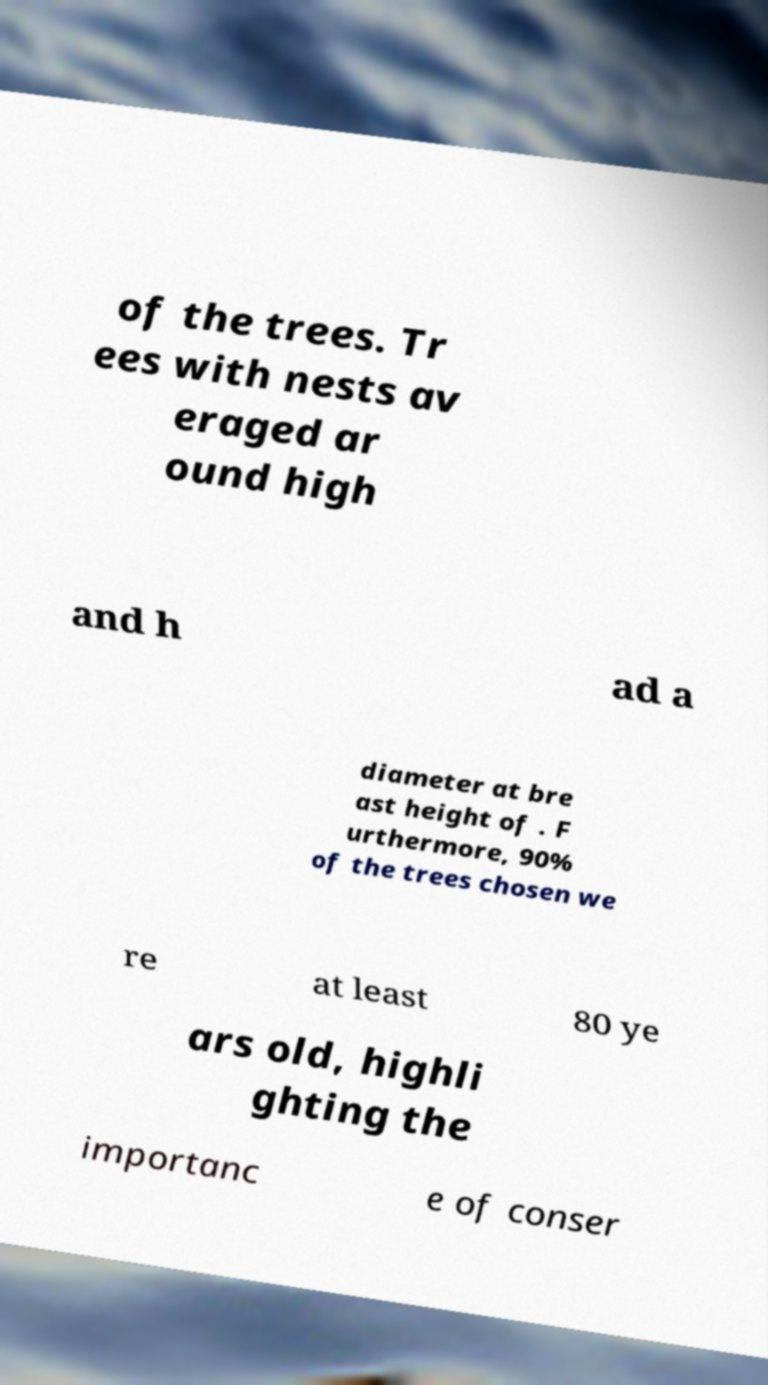Could you assist in decoding the text presented in this image and type it out clearly? of the trees. Tr ees with nests av eraged ar ound high and h ad a diameter at bre ast height of . F urthermore, 90% of the trees chosen we re at least 80 ye ars old, highli ghting the importanc e of conser 